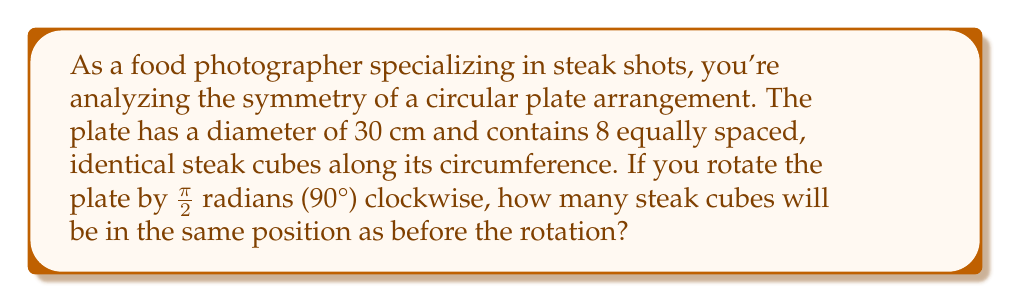Can you answer this question? Let's approach this step-by-step:

1) First, we need to understand the concept of rotational symmetry. An object has rotational symmetry if it looks the same after a certain amount of rotation.

2) In this case, we have 8 equally spaced steak cubes around a circular plate. This means the plate has 8-fold rotational symmetry.

3) The angle between each steak cube is:
   $$\theta = \frac{2\pi}{8} = \frac{\pi}{4} \text{ radians} = 45°$$

4) We're rotating the plate by $\frac{\pi}{2}$ radians or 90°. We need to determine how many $\frac{\pi}{4}$ rotations this is equivalent to:
   $$\frac{\pi/2}{\pi/4} = 2$$

5) This means the rotation moves each steak cube 2 positions clockwise.

6) To find how many cubes remain in the same position, we need to solve the equation:
   $$2x \equiv 0 \pmod{8}$$
   where $x$ is the number of positions a cube needs to move to return to its original position.

7) The solutions to this equation are $x = 0$ and $x = 4$, as $2 \cdot 0 = 0$ and $2 \cdot 4 = 8 \equiv 0 \pmod{8}$.

8) This means that the cubes in positions 0 and 4 (considering 0 as the starting position and counting clockwise) will return to their original positions after the rotation.

[asy]
unitsize(0.15cm);
draw(circle((0,0),15));
for(int i=0; i<8; ++i) {
    dot((15*cos(pi/4*i), 15*sin(pi/4*i)), red);
}
label("0", (17,0), E);
label("4", (-17,0), W);
[/asy]

Therefore, 2 steak cubes will be in the same position after the rotation.
Answer: 2 steak cubes 